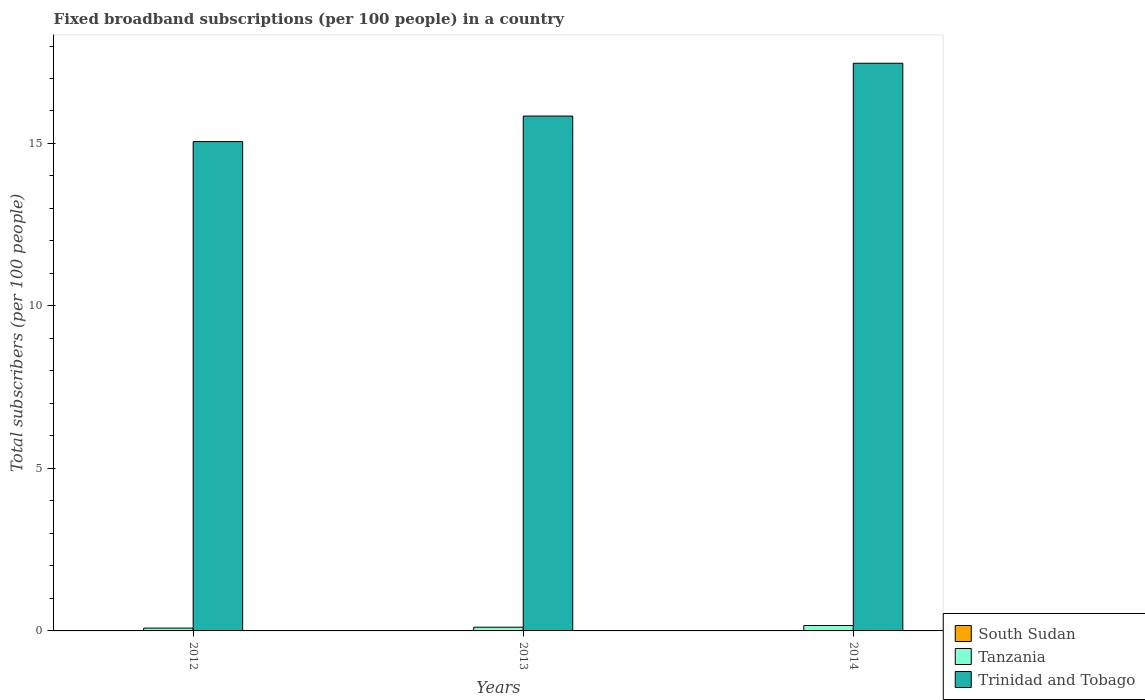How many groups of bars are there?
Provide a succinct answer. 3. Are the number of bars on each tick of the X-axis equal?
Make the answer very short. Yes. What is the number of broadband subscriptions in Trinidad and Tobago in 2012?
Your response must be concise. 15.06. Across all years, what is the maximum number of broadband subscriptions in Tanzania?
Ensure brevity in your answer.  0.17. Across all years, what is the minimum number of broadband subscriptions in Trinidad and Tobago?
Make the answer very short. 15.06. In which year was the number of broadband subscriptions in South Sudan minimum?
Provide a short and direct response. 2012. What is the total number of broadband subscriptions in South Sudan in the graph?
Offer a terse response. 0. What is the difference between the number of broadband subscriptions in South Sudan in 2013 and that in 2014?
Give a very brief answer. 3.33737826877041e-5. What is the difference between the number of broadband subscriptions in South Sudan in 2014 and the number of broadband subscriptions in Tanzania in 2012?
Your answer should be compact. -0.09. What is the average number of broadband subscriptions in Tanzania per year?
Keep it short and to the point. 0.12. In the year 2012, what is the difference between the number of broadband subscriptions in South Sudan and number of broadband subscriptions in Trinidad and Tobago?
Give a very brief answer. -15.06. What is the ratio of the number of broadband subscriptions in Trinidad and Tobago in 2013 to that in 2014?
Your answer should be very brief. 0.91. Is the difference between the number of broadband subscriptions in South Sudan in 2012 and 2014 greater than the difference between the number of broadband subscriptions in Trinidad and Tobago in 2012 and 2014?
Ensure brevity in your answer.  Yes. What is the difference between the highest and the second highest number of broadband subscriptions in Trinidad and Tobago?
Your answer should be very brief. 1.62. What is the difference between the highest and the lowest number of broadband subscriptions in Tanzania?
Offer a very short reply. 0.08. What does the 1st bar from the left in 2012 represents?
Keep it short and to the point. South Sudan. What does the 3rd bar from the right in 2012 represents?
Ensure brevity in your answer.  South Sudan. Is it the case that in every year, the sum of the number of broadband subscriptions in Trinidad and Tobago and number of broadband subscriptions in South Sudan is greater than the number of broadband subscriptions in Tanzania?
Your answer should be very brief. Yes. Are all the bars in the graph horizontal?
Your response must be concise. No. What is the difference between two consecutive major ticks on the Y-axis?
Your response must be concise. 5. Does the graph contain any zero values?
Your response must be concise. No. How are the legend labels stacked?
Ensure brevity in your answer.  Vertical. What is the title of the graph?
Keep it short and to the point. Fixed broadband subscriptions (per 100 people) in a country. What is the label or title of the Y-axis?
Offer a terse response. Total subscribers (per 100 people). What is the Total subscribers (per 100 people) of South Sudan in 2012?
Ensure brevity in your answer.  0. What is the Total subscribers (per 100 people) of Tanzania in 2012?
Provide a succinct answer. 0.09. What is the Total subscribers (per 100 people) of Trinidad and Tobago in 2012?
Your response must be concise. 15.06. What is the Total subscribers (per 100 people) in South Sudan in 2013?
Provide a short and direct response. 0. What is the Total subscribers (per 100 people) of Tanzania in 2013?
Give a very brief answer. 0.11. What is the Total subscribers (per 100 people) in Trinidad and Tobago in 2013?
Give a very brief answer. 15.84. What is the Total subscribers (per 100 people) of South Sudan in 2014?
Provide a short and direct response. 0. What is the Total subscribers (per 100 people) of Tanzania in 2014?
Make the answer very short. 0.17. What is the Total subscribers (per 100 people) of Trinidad and Tobago in 2014?
Your answer should be very brief. 17.47. Across all years, what is the maximum Total subscribers (per 100 people) in South Sudan?
Make the answer very short. 0. Across all years, what is the maximum Total subscribers (per 100 people) in Tanzania?
Offer a terse response. 0.17. Across all years, what is the maximum Total subscribers (per 100 people) of Trinidad and Tobago?
Offer a terse response. 17.47. Across all years, what is the minimum Total subscribers (per 100 people) in South Sudan?
Give a very brief answer. 0. Across all years, what is the minimum Total subscribers (per 100 people) of Tanzania?
Offer a terse response. 0.09. Across all years, what is the minimum Total subscribers (per 100 people) of Trinidad and Tobago?
Your answer should be very brief. 15.06. What is the total Total subscribers (per 100 people) of South Sudan in the graph?
Your response must be concise. 0. What is the total Total subscribers (per 100 people) in Tanzania in the graph?
Offer a very short reply. 0.37. What is the total Total subscribers (per 100 people) in Trinidad and Tobago in the graph?
Make the answer very short. 48.37. What is the difference between the Total subscribers (per 100 people) of South Sudan in 2012 and that in 2013?
Your response must be concise. -0. What is the difference between the Total subscribers (per 100 people) of Tanzania in 2012 and that in 2013?
Offer a terse response. -0.03. What is the difference between the Total subscribers (per 100 people) of Trinidad and Tobago in 2012 and that in 2013?
Your response must be concise. -0.79. What is the difference between the Total subscribers (per 100 people) of South Sudan in 2012 and that in 2014?
Your answer should be very brief. -0. What is the difference between the Total subscribers (per 100 people) of Tanzania in 2012 and that in 2014?
Keep it short and to the point. -0.08. What is the difference between the Total subscribers (per 100 people) of Trinidad and Tobago in 2012 and that in 2014?
Provide a short and direct response. -2.41. What is the difference between the Total subscribers (per 100 people) of Tanzania in 2013 and that in 2014?
Your answer should be very brief. -0.05. What is the difference between the Total subscribers (per 100 people) of Trinidad and Tobago in 2013 and that in 2014?
Ensure brevity in your answer.  -1.62. What is the difference between the Total subscribers (per 100 people) of South Sudan in 2012 and the Total subscribers (per 100 people) of Tanzania in 2013?
Provide a short and direct response. -0.11. What is the difference between the Total subscribers (per 100 people) in South Sudan in 2012 and the Total subscribers (per 100 people) in Trinidad and Tobago in 2013?
Keep it short and to the point. -15.84. What is the difference between the Total subscribers (per 100 people) in Tanzania in 2012 and the Total subscribers (per 100 people) in Trinidad and Tobago in 2013?
Provide a succinct answer. -15.76. What is the difference between the Total subscribers (per 100 people) in South Sudan in 2012 and the Total subscribers (per 100 people) in Tanzania in 2014?
Your response must be concise. -0.17. What is the difference between the Total subscribers (per 100 people) in South Sudan in 2012 and the Total subscribers (per 100 people) in Trinidad and Tobago in 2014?
Provide a short and direct response. -17.47. What is the difference between the Total subscribers (per 100 people) in Tanzania in 2012 and the Total subscribers (per 100 people) in Trinidad and Tobago in 2014?
Ensure brevity in your answer.  -17.38. What is the difference between the Total subscribers (per 100 people) in South Sudan in 2013 and the Total subscribers (per 100 people) in Tanzania in 2014?
Offer a terse response. -0.17. What is the difference between the Total subscribers (per 100 people) of South Sudan in 2013 and the Total subscribers (per 100 people) of Trinidad and Tobago in 2014?
Offer a very short reply. -17.47. What is the difference between the Total subscribers (per 100 people) of Tanzania in 2013 and the Total subscribers (per 100 people) of Trinidad and Tobago in 2014?
Give a very brief answer. -17.35. What is the average Total subscribers (per 100 people) in South Sudan per year?
Your answer should be very brief. 0. What is the average Total subscribers (per 100 people) in Tanzania per year?
Provide a short and direct response. 0.12. What is the average Total subscribers (per 100 people) in Trinidad and Tobago per year?
Keep it short and to the point. 16.12. In the year 2012, what is the difference between the Total subscribers (per 100 people) of South Sudan and Total subscribers (per 100 people) of Tanzania?
Ensure brevity in your answer.  -0.09. In the year 2012, what is the difference between the Total subscribers (per 100 people) of South Sudan and Total subscribers (per 100 people) of Trinidad and Tobago?
Make the answer very short. -15.06. In the year 2012, what is the difference between the Total subscribers (per 100 people) in Tanzania and Total subscribers (per 100 people) in Trinidad and Tobago?
Your answer should be compact. -14.97. In the year 2013, what is the difference between the Total subscribers (per 100 people) in South Sudan and Total subscribers (per 100 people) in Tanzania?
Give a very brief answer. -0.11. In the year 2013, what is the difference between the Total subscribers (per 100 people) in South Sudan and Total subscribers (per 100 people) in Trinidad and Tobago?
Provide a short and direct response. -15.84. In the year 2013, what is the difference between the Total subscribers (per 100 people) in Tanzania and Total subscribers (per 100 people) in Trinidad and Tobago?
Provide a short and direct response. -15.73. In the year 2014, what is the difference between the Total subscribers (per 100 people) in South Sudan and Total subscribers (per 100 people) in Tanzania?
Your response must be concise. -0.17. In the year 2014, what is the difference between the Total subscribers (per 100 people) of South Sudan and Total subscribers (per 100 people) of Trinidad and Tobago?
Keep it short and to the point. -17.47. In the year 2014, what is the difference between the Total subscribers (per 100 people) of Tanzania and Total subscribers (per 100 people) of Trinidad and Tobago?
Give a very brief answer. -17.3. What is the ratio of the Total subscribers (per 100 people) of South Sudan in 2012 to that in 2013?
Keep it short and to the point. 0.18. What is the ratio of the Total subscribers (per 100 people) in Tanzania in 2012 to that in 2013?
Your answer should be compact. 0.75. What is the ratio of the Total subscribers (per 100 people) of Trinidad and Tobago in 2012 to that in 2013?
Offer a very short reply. 0.95. What is the ratio of the Total subscribers (per 100 people) of South Sudan in 2012 to that in 2014?
Offer a very short reply. 0.18. What is the ratio of the Total subscribers (per 100 people) in Tanzania in 2012 to that in 2014?
Your answer should be compact. 0.52. What is the ratio of the Total subscribers (per 100 people) of Trinidad and Tobago in 2012 to that in 2014?
Your answer should be very brief. 0.86. What is the ratio of the Total subscribers (per 100 people) in South Sudan in 2013 to that in 2014?
Give a very brief answer. 1.04. What is the ratio of the Total subscribers (per 100 people) in Tanzania in 2013 to that in 2014?
Make the answer very short. 0.69. What is the ratio of the Total subscribers (per 100 people) of Trinidad and Tobago in 2013 to that in 2014?
Make the answer very short. 0.91. What is the difference between the highest and the second highest Total subscribers (per 100 people) in South Sudan?
Ensure brevity in your answer.  0. What is the difference between the highest and the second highest Total subscribers (per 100 people) in Tanzania?
Offer a terse response. 0.05. What is the difference between the highest and the second highest Total subscribers (per 100 people) of Trinidad and Tobago?
Provide a short and direct response. 1.62. What is the difference between the highest and the lowest Total subscribers (per 100 people) of South Sudan?
Your response must be concise. 0. What is the difference between the highest and the lowest Total subscribers (per 100 people) of Tanzania?
Offer a terse response. 0.08. What is the difference between the highest and the lowest Total subscribers (per 100 people) of Trinidad and Tobago?
Your answer should be very brief. 2.41. 